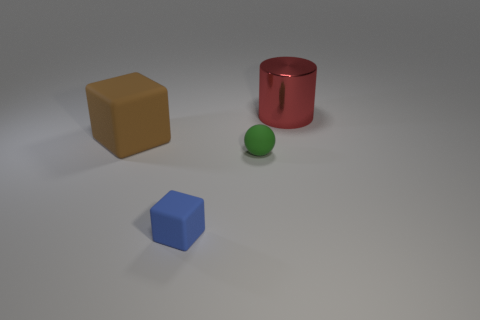Do the objects cast shadows, and what does this tell us about the light source? Yes, each object casts a shadow. This indicates that there is a light source in the scene, positioned in such a manner that it creates visible shadows to the opposite side of the objects. It suggests the light is directional and coming from above, possibly at a slight angle. 